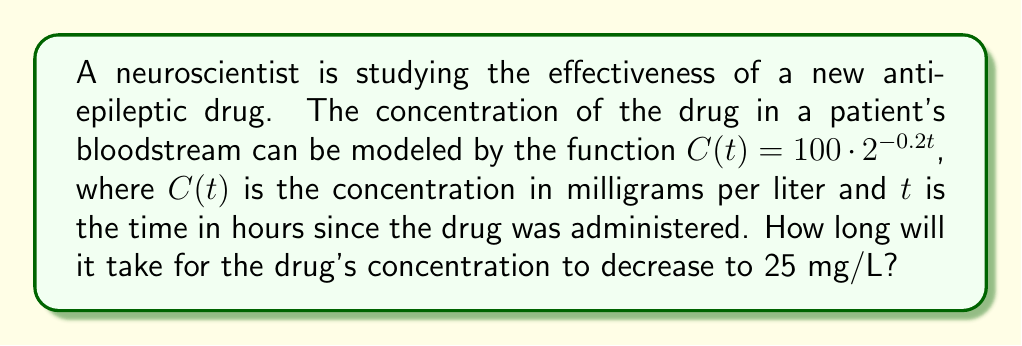Show me your answer to this math problem. Let's approach this step-by-step:

1) We're given the function $C(t) = 100 \cdot 2^{-0.2t}$

2) We want to find $t$ when $C(t) = 25$. So, let's set up the equation:

   $25 = 100 \cdot 2^{-0.2t}$

3) Divide both sides by 100:

   $0.25 = 2^{-0.2t}$

4) Now, we can apply the logarithm (base 2) to both sides:

   $\log_2(0.25) = \log_2(2^{-0.2t})$

5) Using the logarithm property $\log_a(a^x) = x$, we get:

   $\log_2(0.25) = -0.2t$

6) Now, let's solve for $t$:

   $t = -\frac{\log_2(0.25)}{0.2}$

7) We can calculate $\log_2(0.25)$:
   
   $\log_2(0.25) = \log_2(\frac{1}{4}) = -2$

8) Substituting this value:

   $t = -\frac{-2}{0.2} = 10$

Therefore, it will take 10 hours for the drug's concentration to decrease to 25 mg/L.
Answer: 10 hours 